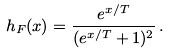Convert formula to latex. <formula><loc_0><loc_0><loc_500><loc_500>h _ { F } ( x ) = \frac { e ^ { x / T } } { ( e ^ { x / T } + 1 ) ^ { 2 } } \, .</formula> 